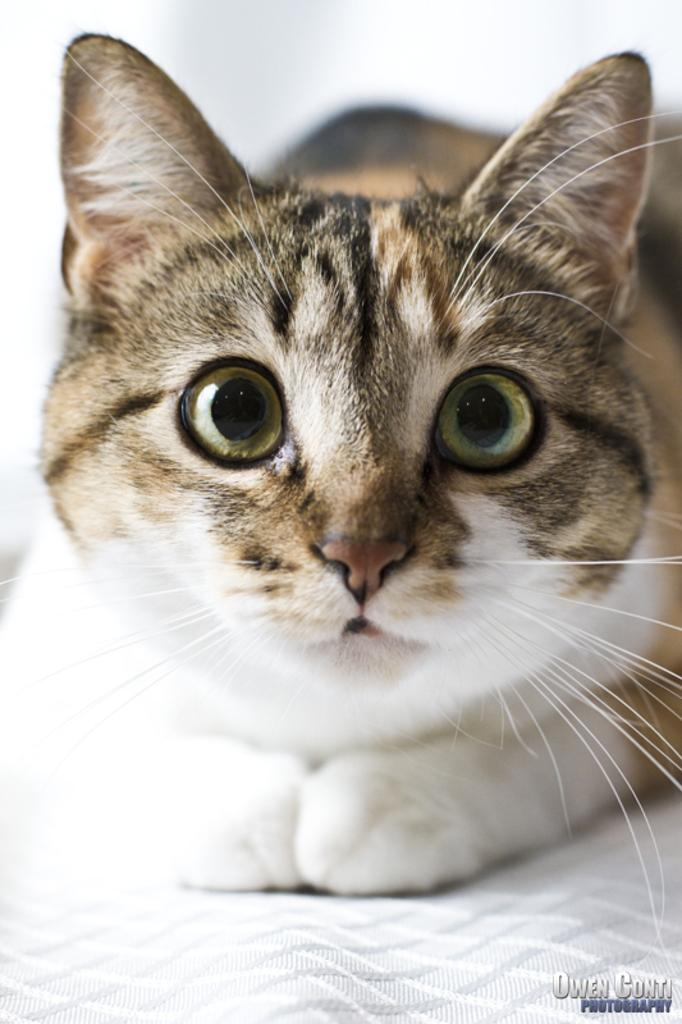What animal is present in the image? There is a cat in the image. What is the cat sitting on? The cat is on a white cloth. Are there any words or letters visible in the image? Yes, there is text visible in the image. How would you describe the background of the image? The background of the image is blurred. What type of wire can be seen holding up the mist in the image? There is no wire or mist present in the image; it features a cat on a white cloth with visible text and a blurred background. 